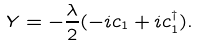Convert formula to latex. <formula><loc_0><loc_0><loc_500><loc_500>Y = - \frac { \lambda } { 2 } ( - i c _ { 1 } + i c _ { 1 } ^ { \dagger } ) .</formula> 